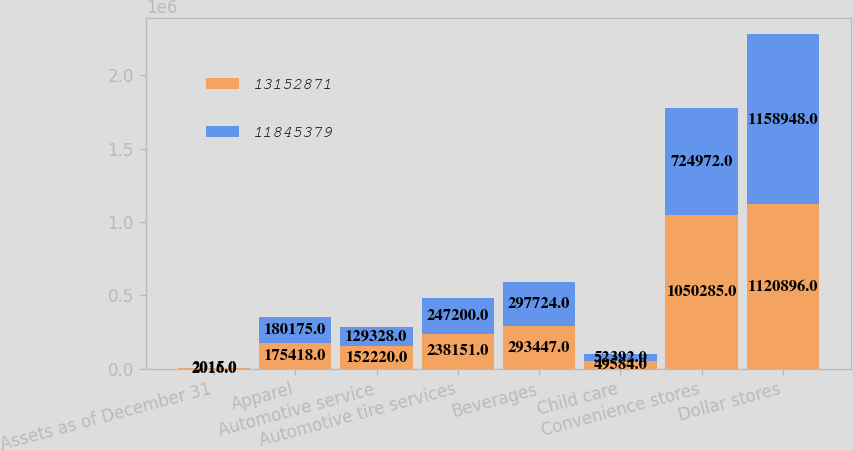<chart> <loc_0><loc_0><loc_500><loc_500><stacked_bar_chart><ecel><fcel>Assets as of December 31<fcel>Apparel<fcel>Automotive service<fcel>Automotive tire services<fcel>Beverages<fcel>Child care<fcel>Convenience stores<fcel>Dollar stores<nl><fcel>1.31529e+07<fcel>2016<fcel>175418<fcel>152220<fcel>238151<fcel>293447<fcel>49584<fcel>1.05028e+06<fcel>1.1209e+06<nl><fcel>1.18454e+07<fcel>2015<fcel>180175<fcel>129328<fcel>247200<fcel>297724<fcel>52392<fcel>724972<fcel>1.15895e+06<nl></chart> 